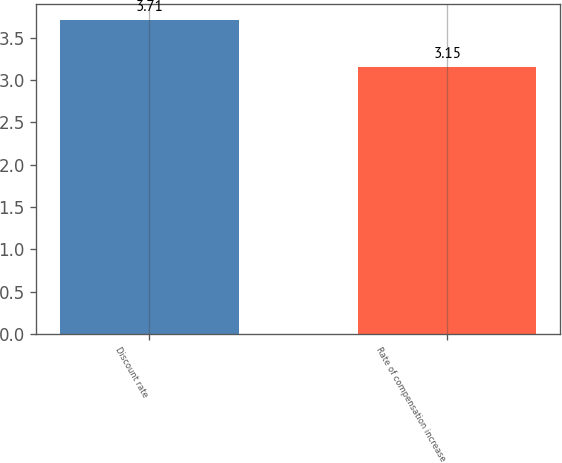Convert chart. <chart><loc_0><loc_0><loc_500><loc_500><bar_chart><fcel>Discount rate<fcel>Rate of compensation increase<nl><fcel>3.71<fcel>3.15<nl></chart> 